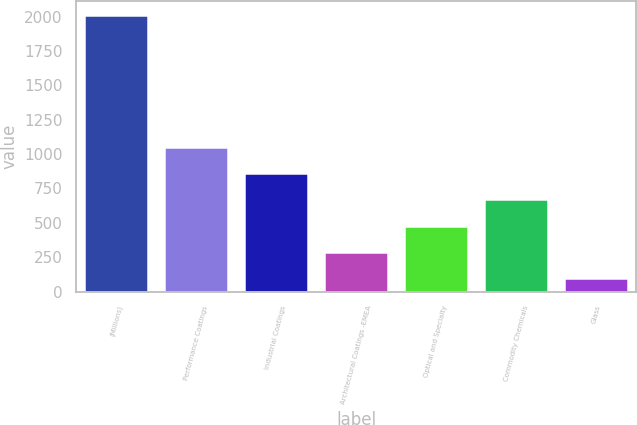Convert chart to OTSL. <chart><loc_0><loc_0><loc_500><loc_500><bar_chart><fcel>(Millions)<fcel>Performance Coatings<fcel>Industrial Coatings<fcel>Architectural Coatings -EMEA<fcel>Optical and Specialty<fcel>Commodity Chemicals<fcel>Glass<nl><fcel>2011<fcel>1054<fcel>862.6<fcel>288.4<fcel>479.8<fcel>671.2<fcel>97<nl></chart> 